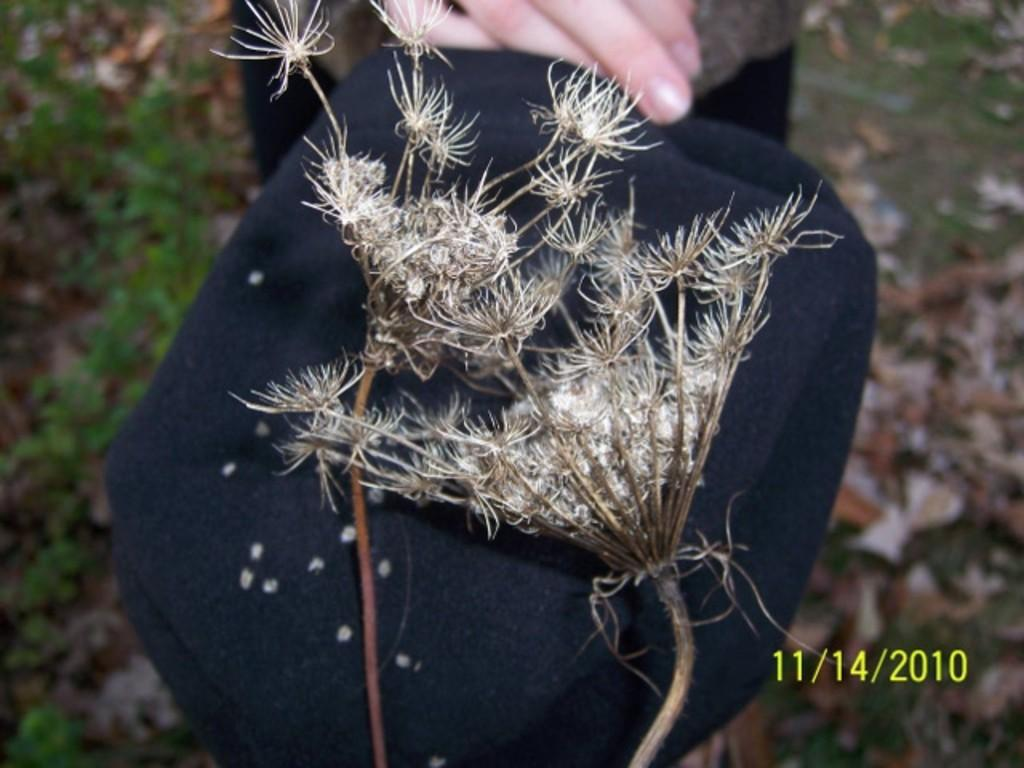What is located in the foreground of the image? There is a cloth in the foreground of the image. What decorative elements are present on the cloth? There are flowers on the cloth. Can you describe the person in the background of the image? Unfortunately, the facts provided do not give any details about the person in the background. What type of natural environment is visible in the image? Grass is visible at the bottom of the image, suggesting a natural environment. What type of theory is being discussed by the person in the image? There is no person actively discussing a theory in the image, as the facts provided do not mention any conversation or interaction. Can you tell me how many needles are present on the cloth? There is no mention of needles in the image, so it is impossible to determine their presence or quantity. 